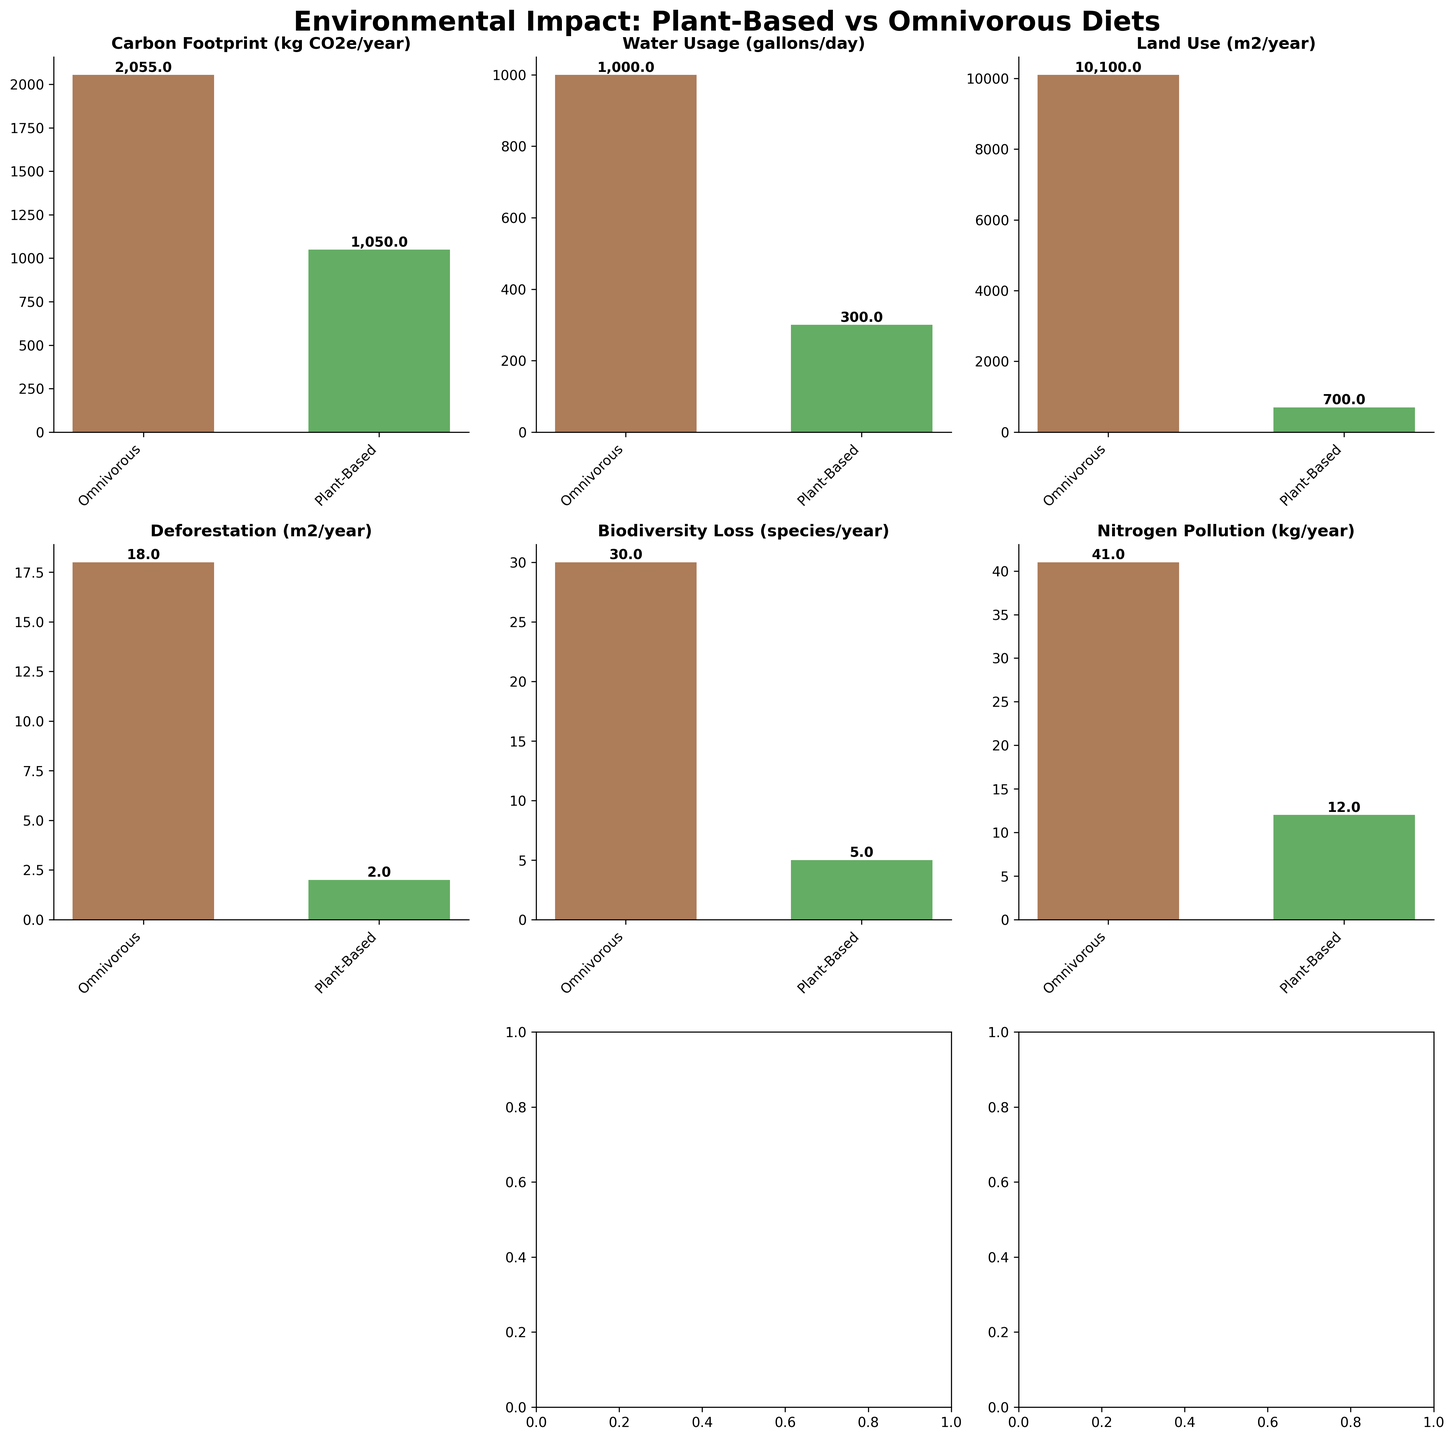What is the title of the figure? The title of the figure is located at the top of the subplot and is written in a large, bold font. It summarizes the main topic of the figure.
Answer: Environmental Impact: Plant-Based vs Omnivorous Diets Which category shows the smallest difference in environmental impact between the two diets? To determine the smallest difference, you need to calculate the difference between the omnivorous and plant-based impacts for each category and identify the smallest value. From the values: Carbon Footprint (2055 - 1050), Water Usage (1000 - 300), Land Use (10100 - 700), Deforestation (18 - 2), Biodiversity Loss (30 - 5), Nitrogen Pollution (41 - 12), Phosphorus Pollution (2.9 - 0.8), the smallest difference is in the Phosphorus Pollution category, which is 2.9 - 0.8 = 2.1.
Answer: Phosphorus Pollution What is the color used to represent the plant-based diet in the figure? By observing the bar colors in the figure, the bar corresponding to the plant-based diet is green.
Answer: Green How much lower is the carbon footprint of a plant-based diet compared to an omnivorous diet? To find the difference, subtract the carbon footprint of the plant-based diet from that of the omnivorous diet. Specifically, 2055 kg CO2e/year - 1050 kg CO2e/year = 1005 kg CO2e/year.
Answer: 1005 kg CO2e/year On which axis are the categories labeled? The categories are listed as titles of the subplots, indicating the type of environmental impact measured in each subplot.
Answer: The categories are labeled as subplot titles Which diet has lower nitrogen pollution? By comparing the heights of the bars in the Nitrogen Pollution subplot, the plant-based diet has a lower nitrogen pollution value.
Answer: Plant-Based Diet What is the sum of water usage per day for both diets? To find the total water usage for both diets, add the values for omnivorous and plant-based diets: 1000 gallons/day (omnivorous) + 300 gallons/day (plant-based) = 1300 gallons/day.
Answer: 1300 gallons/day How many subplots are prominently displayed in the figure? The figure consists of a grid of subplots, with a total of 3 rows and 3 columns. However, one subplot is intentionally left blank, leaving a total of 8 prominently displayed subplots.
Answer: 8 